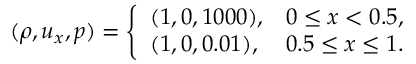Convert formula to latex. <formula><loc_0><loc_0><loc_500><loc_500>( \rho , u _ { x } , p ) = \left \{ \begin{array} { l l } { ( 1 , 0 , 1 0 0 0 ) , } & { 0 \leq x < 0 . 5 , } \\ { ( 1 , 0 , 0 . 0 1 ) , } & { 0 . 5 \leq x \leq 1 . } \end{array}</formula> 